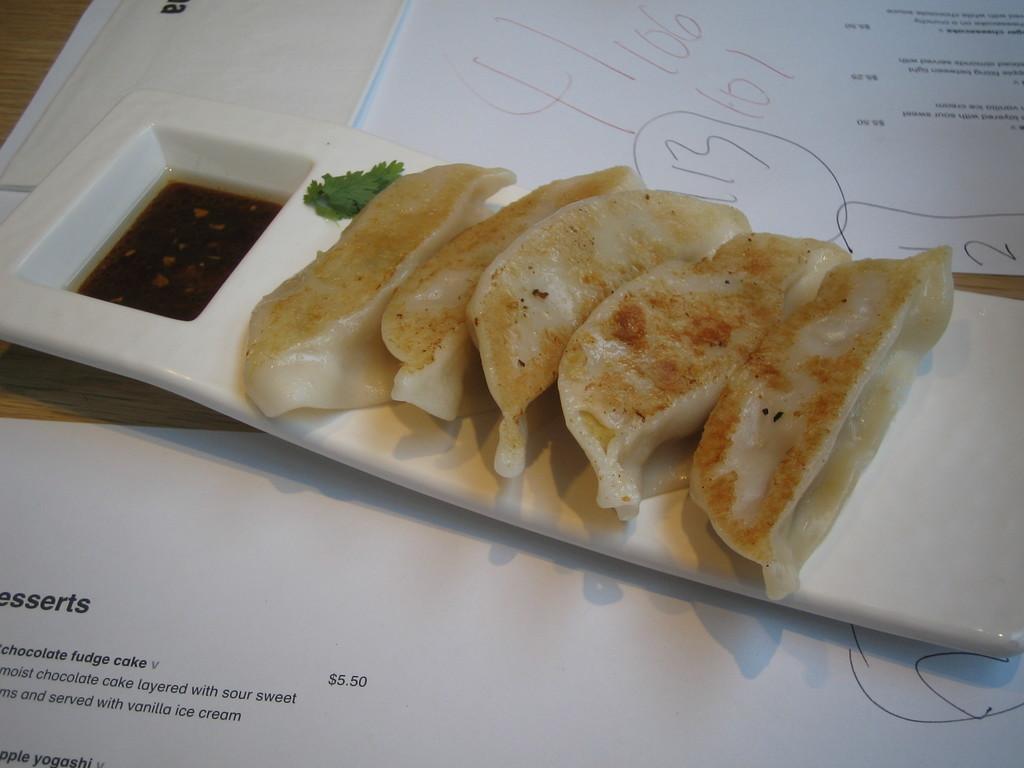Could you give a brief overview of what you see in this image? In this image I can see there are food items on a white color plate, at the bottom there are papers. 